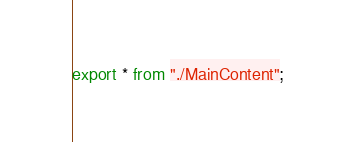<code> <loc_0><loc_0><loc_500><loc_500><_TypeScript_>export * from "./MainContent";
</code> 